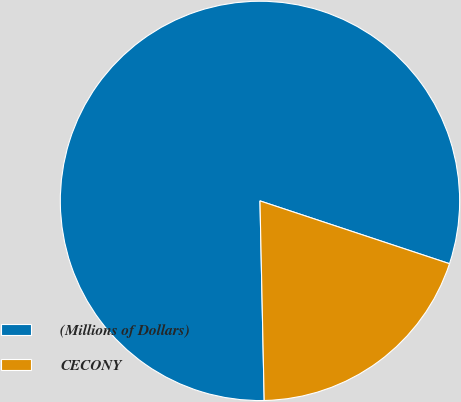Convert chart. <chart><loc_0><loc_0><loc_500><loc_500><pie_chart><fcel>(Millions of Dollars)<fcel>CECONY<nl><fcel>80.43%<fcel>19.57%<nl></chart> 